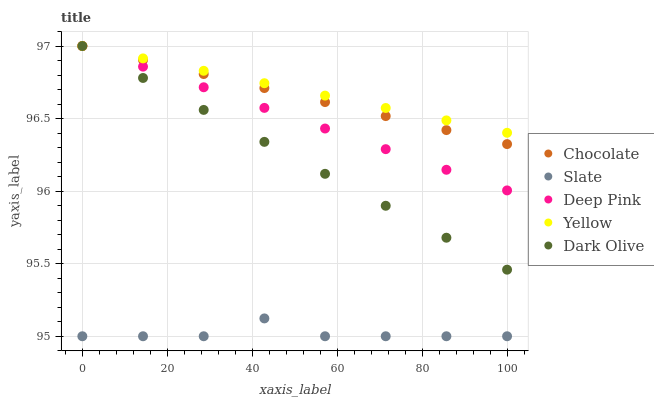Does Slate have the minimum area under the curve?
Answer yes or no. Yes. Does Yellow have the maximum area under the curve?
Answer yes or no. Yes. Does Deep Pink have the minimum area under the curve?
Answer yes or no. No. Does Deep Pink have the maximum area under the curve?
Answer yes or no. No. Is Yellow the smoothest?
Answer yes or no. Yes. Is Slate the roughest?
Answer yes or no. Yes. Is Deep Pink the smoothest?
Answer yes or no. No. Is Deep Pink the roughest?
Answer yes or no. No. Does Slate have the lowest value?
Answer yes or no. Yes. Does Deep Pink have the lowest value?
Answer yes or no. No. Does Chocolate have the highest value?
Answer yes or no. Yes. Does Slate have the highest value?
Answer yes or no. No. Is Slate less than Yellow?
Answer yes or no. Yes. Is Deep Pink greater than Slate?
Answer yes or no. Yes. Does Yellow intersect Deep Pink?
Answer yes or no. Yes. Is Yellow less than Deep Pink?
Answer yes or no. No. Is Yellow greater than Deep Pink?
Answer yes or no. No. Does Slate intersect Yellow?
Answer yes or no. No. 